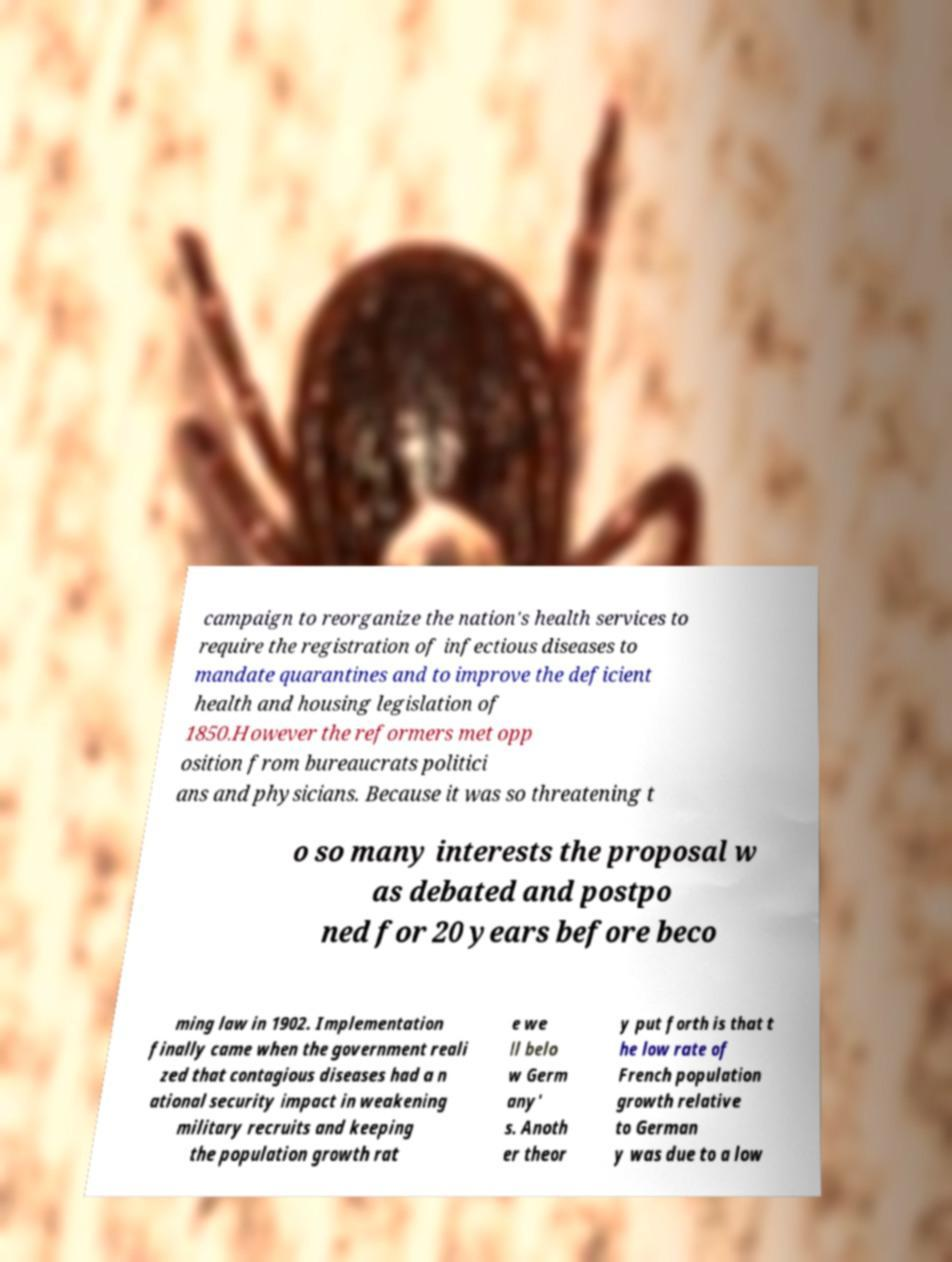What messages or text are displayed in this image? I need them in a readable, typed format. campaign to reorganize the nation's health services to require the registration of infectious diseases to mandate quarantines and to improve the deficient health and housing legislation of 1850.However the reformers met opp osition from bureaucrats politici ans and physicians. Because it was so threatening t o so many interests the proposal w as debated and postpo ned for 20 years before beco ming law in 1902. Implementation finally came when the government reali zed that contagious diseases had a n ational security impact in weakening military recruits and keeping the population growth rat e we ll belo w Germ any' s. Anoth er theor y put forth is that t he low rate of French population growth relative to German y was due to a low 